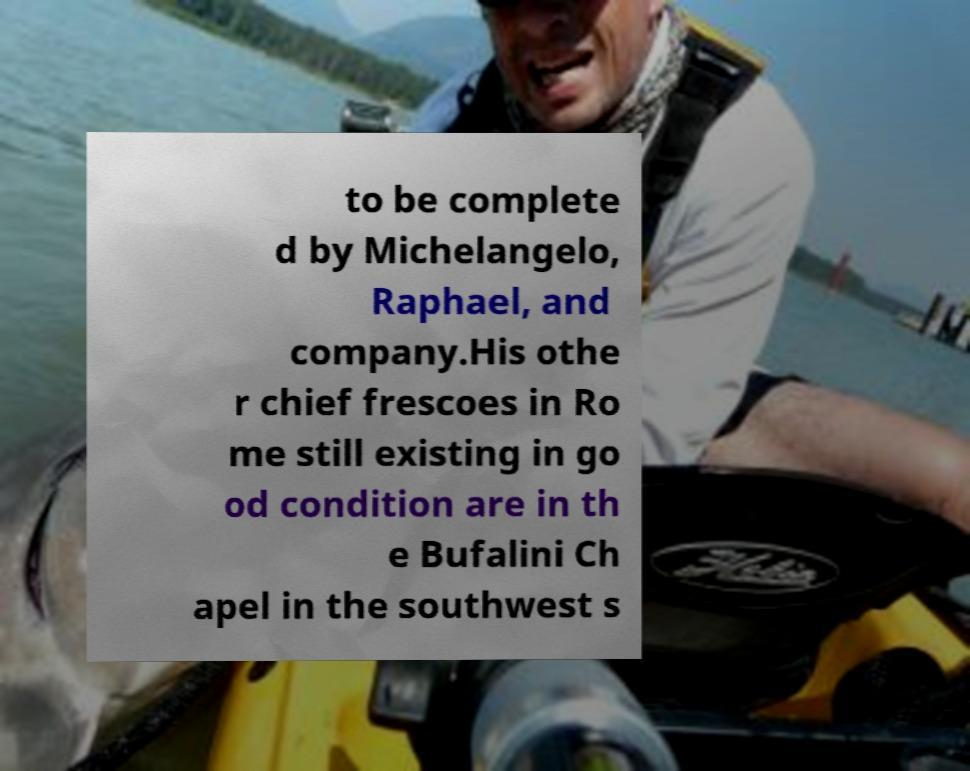Please identify and transcribe the text found in this image. to be complete d by Michelangelo, Raphael, and company.His othe r chief frescoes in Ro me still existing in go od condition are in th e Bufalini Ch apel in the southwest s 